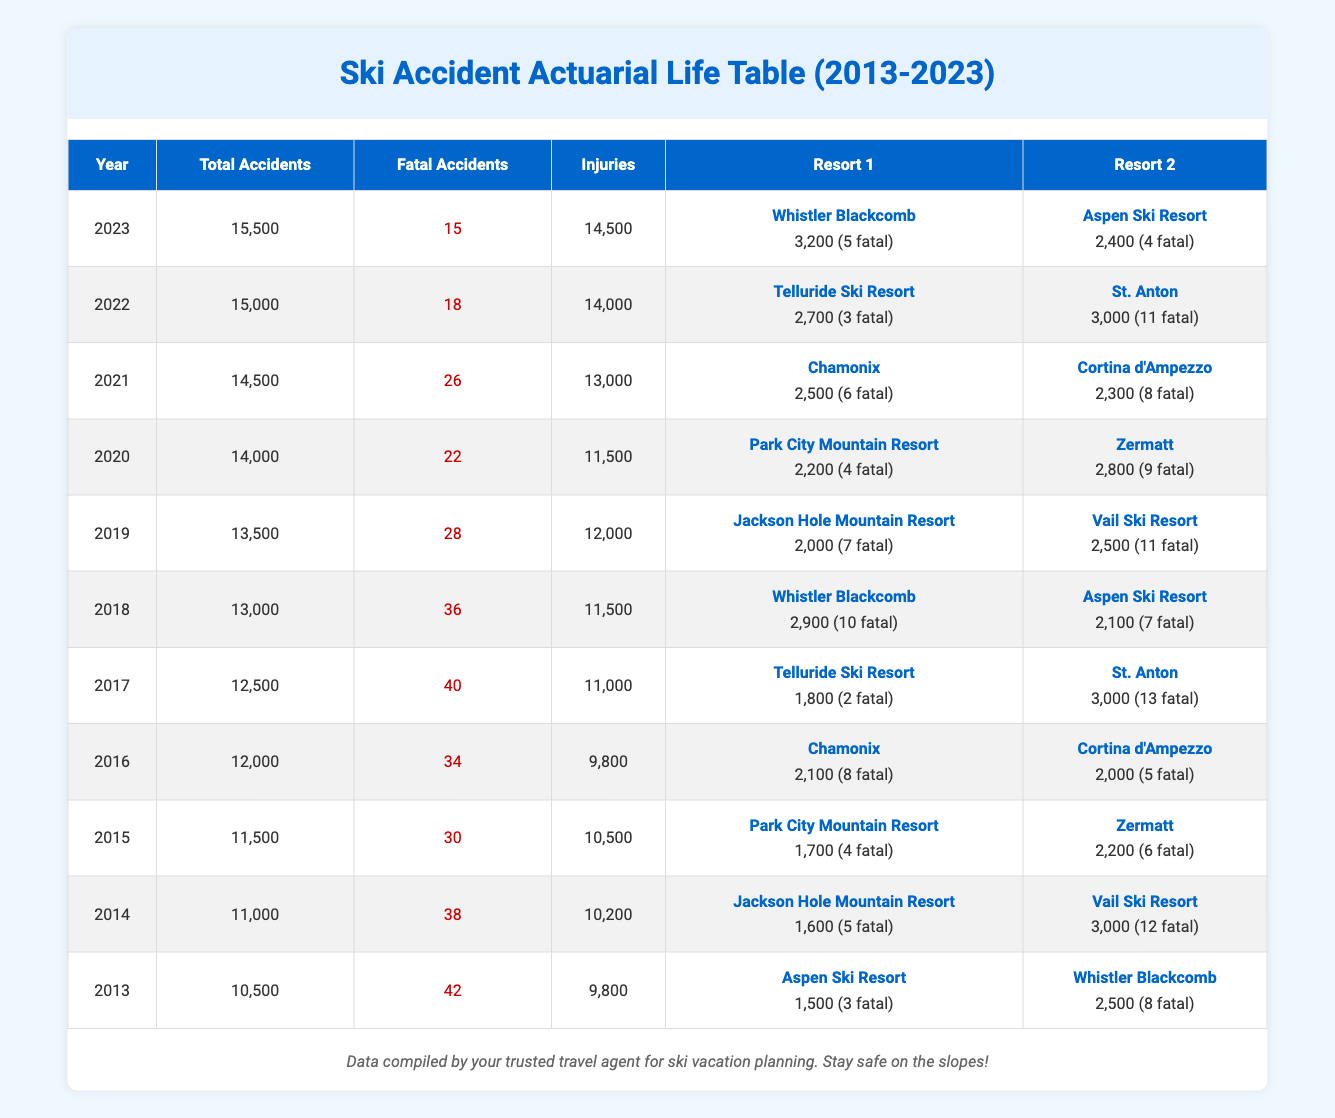What was the total number of fatal accidents in 2018? In the table, under the year 2018, the number of fatal accidents is explicitly stated in the Fatal Accidents column. The total for 2018 is 36.
Answer: 36 Which year had the highest number of total accidents? By comparing the Total Accidents column across all years, I see that 2023 has the highest total with 15,500.
Answer: 2023 What is the average number of fatal accidents from 2013 to 2023? To find the average, I will sum the Fatal Accidents for each year (42 + 38 + 30 + 34 + 40 + 36 + 28 + 22 + 26 + 18 + 15) = 359. There are 11 data points (years), so the average is 359/11 ≈ 32.64.
Answer: 32.64 Did the number of fatalities decrease from 2020 to 2021? Checking the Fatal Accidents column for 2020 shows 22 fatalities, while in 2021, it shows 26. Since 26 is greater than 22, the number of fatalities did not decrease; it increased.
Answer: No Which resort had the highest number of fatal accidents in 2017? In 2017, the Two resorts are listed: Telluride Ski Resort (2 fatalities) and St. Anton (13 fatalities). Comparing the fatal accident numbers, St. Anton had the higher count.
Answer: St. Anton How many total accidents were reported in the year 2019? In the table, the Total Accidents for 2019 is clearly marked in the Total Accidents column, specifically as 13,500.
Answer: 13,500 Which two years had the same number of total accidents? By reviewing the Total Accidents column, I can see that 2018 had 13,000 total accidents and 2017 had 12,500, which are different. On closer inspection, both 2020 and 2021 report 14,000 and 14,500 total accidents respectively; therefore, no years had the same total.
Answer: No matching years What was the increase in the number of injuries from 2016 to 2021? The number of injuries in 2016 is 9,800, and in 2021 it is 13,000. To find the increase, I calculate 13,000 - 9,800 = 3,200, indicating that injuries increased over that period.
Answer: 3,200 